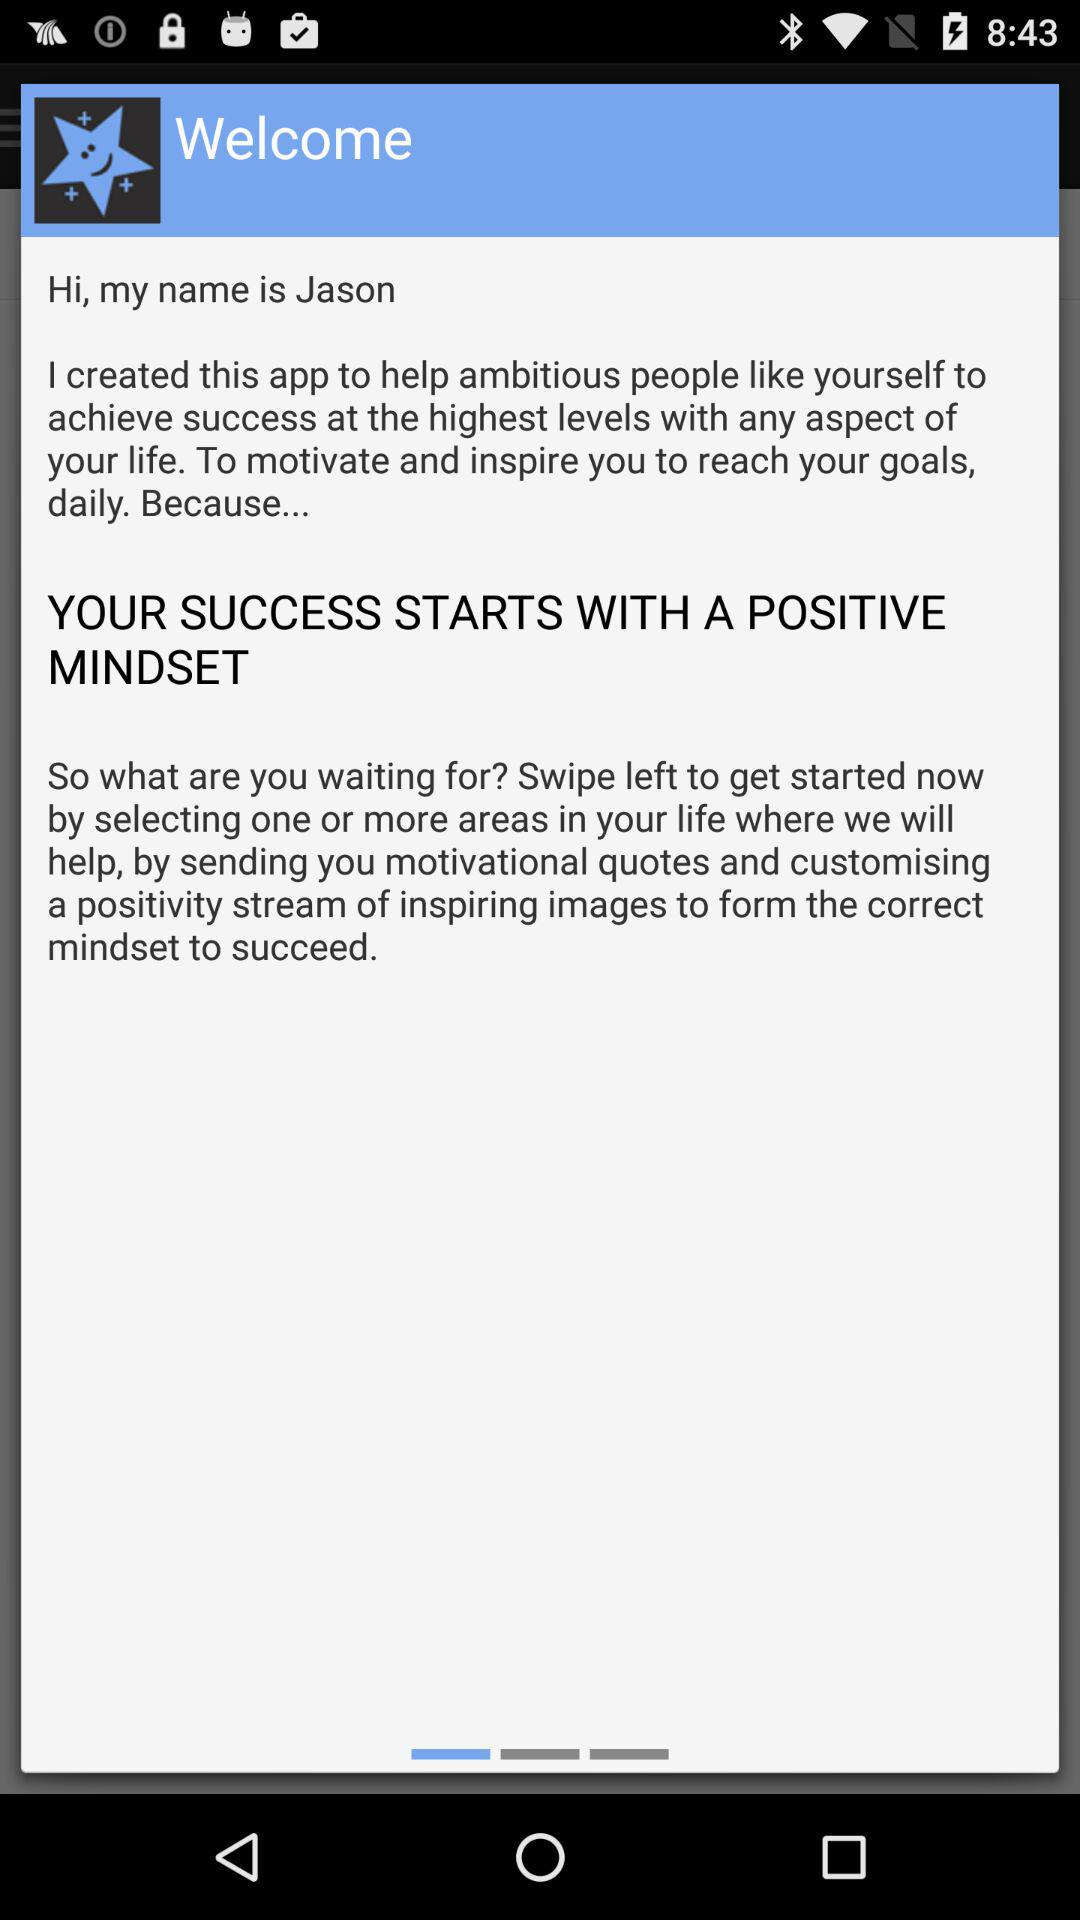What's the application called?
When the provided information is insufficient, respond with <no answer>. <no answer> 